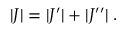<formula> <loc_0><loc_0><loc_500><loc_500>| J | = | J ^ { \prime } | + | J ^ { \prime \prime } | \, .</formula> 